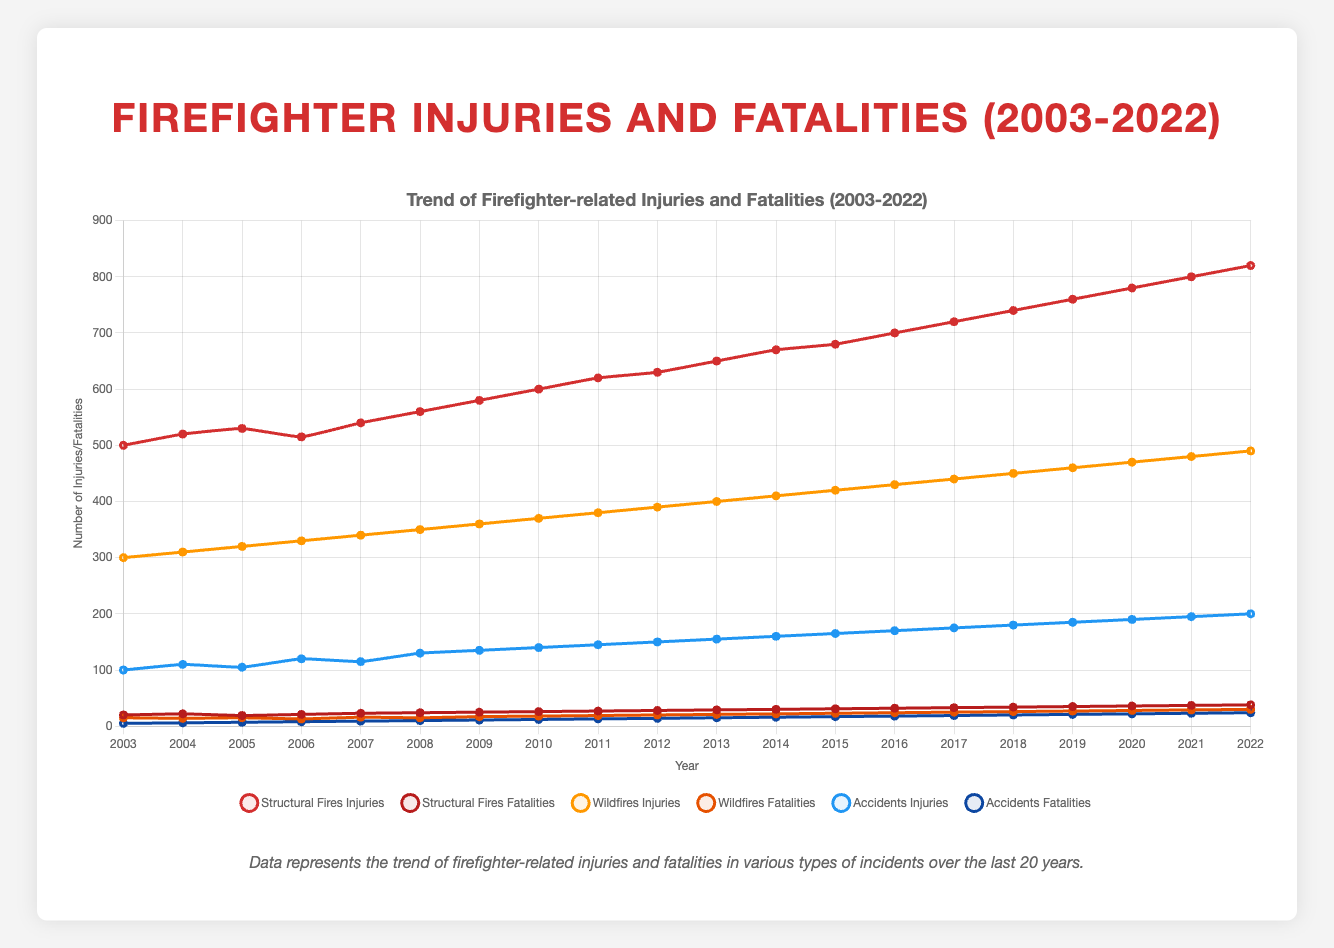What type of incidents had the highest number of injuries in 2022? The line chart shows that structural fires had the highest number of injuries in 2022 with 820 injuries.
Answer: Structural fires How did the number of wildfires fatalities change from 2003 to 2010? The number of wildfires fatalities increased from 15 in 2003 to 18 in 2010.
Answer: Increased by 3 Which year had the highest number of fatalities for accidents? By observing the chart, the highest number of fatalities for accidents occurred in 2022, with 24 fatalities.
Answer: 2022 What is the trend of injuries in structural fires from 2003 to 2022? The line for structural fires injuries rises consistently from 500 in 2003 to 820 in 2022, indicating a continuous upward trend.
Answer: Continuous upward trend Compare the fatality counts in structural fires and wildfires in the year 2015. In 2015, structural fires fatalities were 31, and wildfires fatalities were 23. Structural fires fatalities are higher than wildfires fatalities in 2015.
Answer: Structural fires (31) vs Wildfires (23) What can you say about the changes in accidents injuries over the last 20 years? The chart indicates that the number of injuries from accidents increased from 100 in 2003 to 200 in 2022, showing a doubling over the period.
Answer: Increased from 100 to 200 Are there any years where the fatalities for wildfires decreased compared to the previous year? Yes, in 2004 the wildfires fatalities decreased from 15 in 2003 to 14 in 2004, and in 2006 they decreased from 15 in 2005 to 13 in 2006.
Answer: 2004 and 2006 Calculate the total number of fatalities from all incidents in the year 2010. Add up the fatalities from structural fires (26), wildfires (18), and accidents (12): 26 + 18 + 12 = 56.
Answer: 56 Which type of incident shows the greatest fluctuation in the number of injuries over the analyzed period? By examining the lines' variability, structural fires display the greatest fluctuation with the largest changes in injury numbers.
Answer: Structural fires What's the difference in the number of structural fires fatalities between 2003 and 2022? The number of structural fires fatalities in 2022 was 38, and in 2003 it was 20. The difference is 38 - 20 = 18.
Answer: 18 